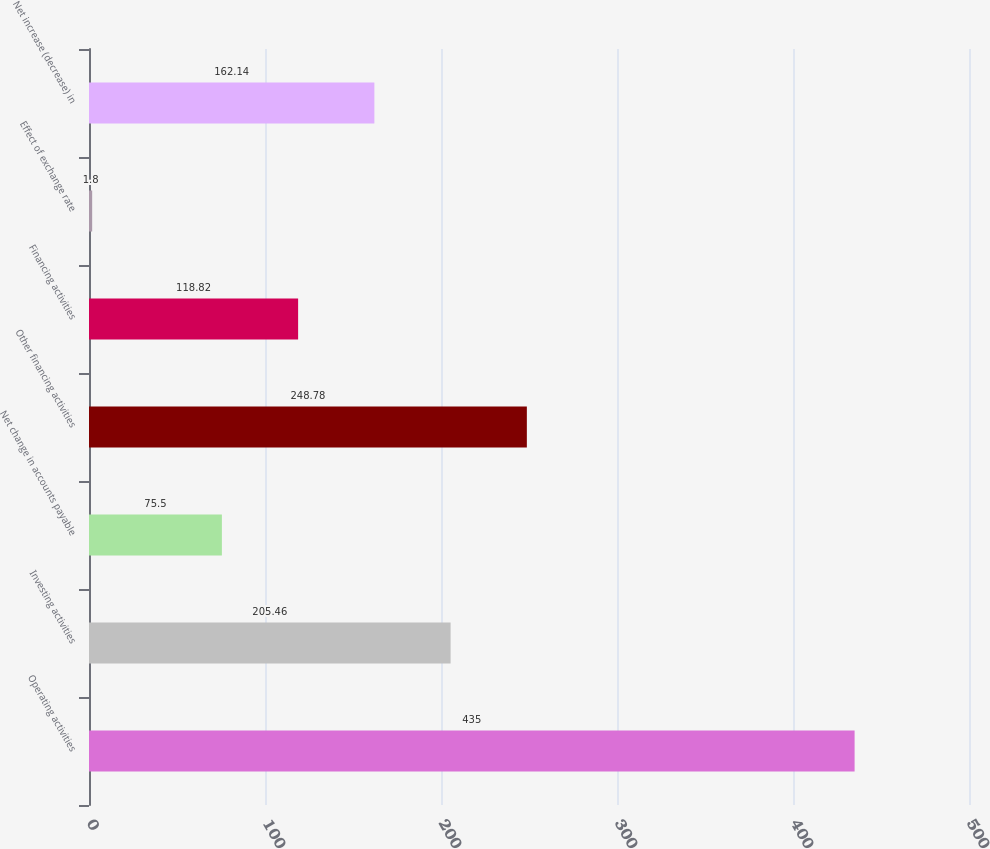Convert chart. <chart><loc_0><loc_0><loc_500><loc_500><bar_chart><fcel>Operating activities<fcel>Investing activities<fcel>Net change in accounts payable<fcel>Other financing activities<fcel>Financing activities<fcel>Effect of exchange rate<fcel>Net increase (decrease) in<nl><fcel>435<fcel>205.46<fcel>75.5<fcel>248.78<fcel>118.82<fcel>1.8<fcel>162.14<nl></chart> 